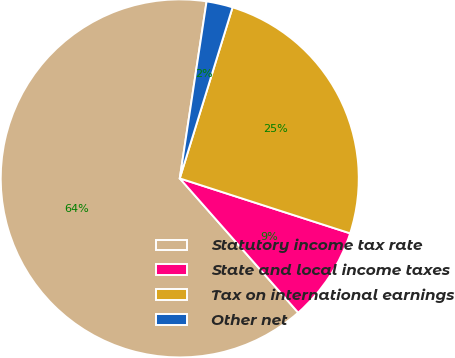Convert chart. <chart><loc_0><loc_0><loc_500><loc_500><pie_chart><fcel>Statutory income tax rate<fcel>State and local income taxes<fcel>Tax on international earnings<fcel>Other net<nl><fcel>63.9%<fcel>8.53%<fcel>25.2%<fcel>2.37%<nl></chart> 